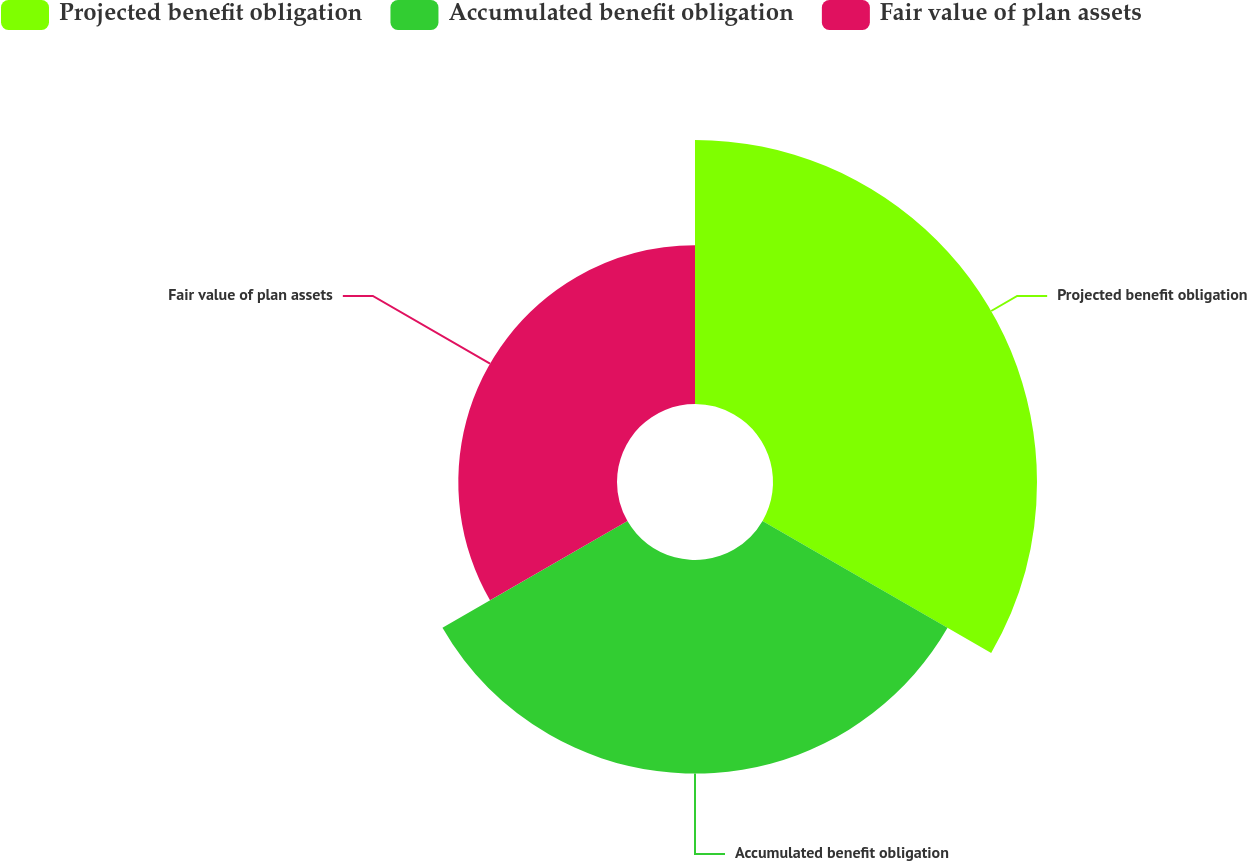<chart> <loc_0><loc_0><loc_500><loc_500><pie_chart><fcel>Projected benefit obligation<fcel>Accumulated benefit obligation<fcel>Fair value of plan assets<nl><fcel>41.49%<fcel>33.57%<fcel>24.94%<nl></chart> 